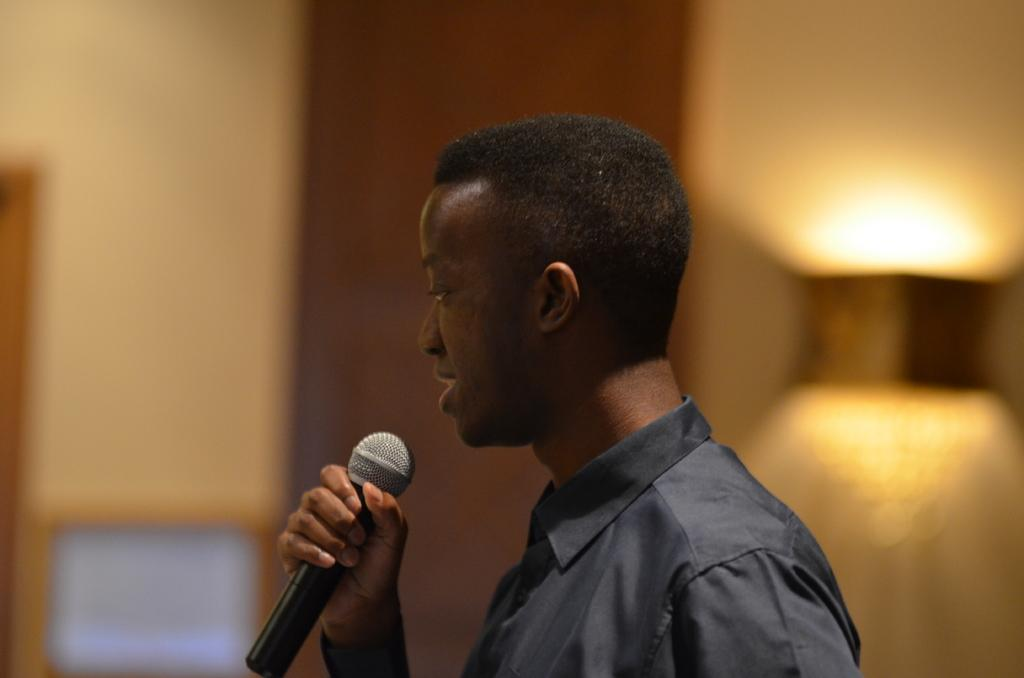What is the main subject of the image? The main subject of the image is a man. What is the man holding in the image? The man is holding a mic. What is the man wearing in the image? The man is wearing a black shirt. What type of summer activity is the man participating in the image? There is no indication of a summer activity in the image; it simply shows a man holding a mic. Can you confirm the existence of a seat in the image? There is no mention of a seat in the image, so it cannot be confirmed. 